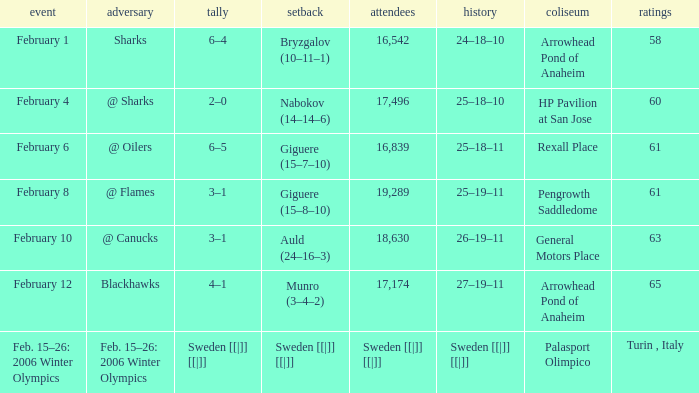Could you help me parse every detail presented in this table? {'header': ['event', 'adversary', 'tally', 'setback', 'attendees', 'history', 'coliseum', 'ratings'], 'rows': [['February 1', 'Sharks', '6–4', 'Bryzgalov (10–11–1)', '16,542', '24–18–10', 'Arrowhead Pond of Anaheim', '58'], ['February 4', '@ Sharks', '2–0', 'Nabokov (14–14–6)', '17,496', '25–18–10', 'HP Pavilion at San Jose', '60'], ['February 6', '@ Oilers', '6–5', 'Giguere (15–7–10)', '16,839', '25–18–11', 'Rexall Place', '61'], ['February 8', '@ Flames', '3–1', 'Giguere (15–8–10)', '19,289', '25–19–11', 'Pengrowth Saddledome', '61'], ['February 10', '@ Canucks', '3–1', 'Auld (24–16–3)', '18,630', '26–19–11', 'General Motors Place', '63'], ['February 12', 'Blackhawks', '4–1', 'Munro (3–4–2)', '17,174', '27–19–11', 'Arrowhead Pond of Anaheim', '65'], ['Feb. 15–26: 2006 Winter Olympics', 'Feb. 15–26: 2006 Winter Olympics', 'Sweden [[|]] [[|]]', 'Sweden [[|]] [[|]]', 'Sweden [[|]] [[|]]', 'Sweden [[|]] [[|]]', 'Palasport Olimpico', 'Turin , Italy']]} What were the points on February 10? 63.0. 